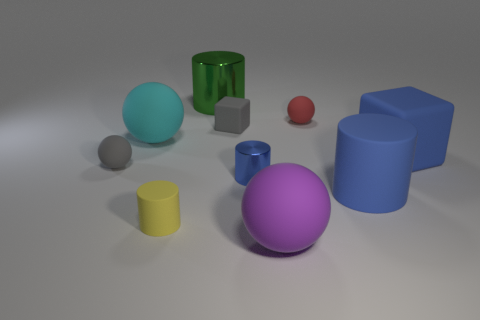Subtract all small yellow rubber cylinders. How many cylinders are left? 3 Subtract all cyan cubes. How many blue cylinders are left? 2 Subtract 1 cylinders. How many cylinders are left? 3 Subtract all gray balls. How many balls are left? 3 Subtract all cubes. How many objects are left? 8 Subtract all gray balls. Subtract all big purple matte objects. How many objects are left? 8 Add 7 big blue objects. How many big blue objects are left? 9 Add 5 tiny blocks. How many tiny blocks exist? 6 Subtract 0 red cylinders. How many objects are left? 10 Subtract all purple spheres. Subtract all purple blocks. How many spheres are left? 3 